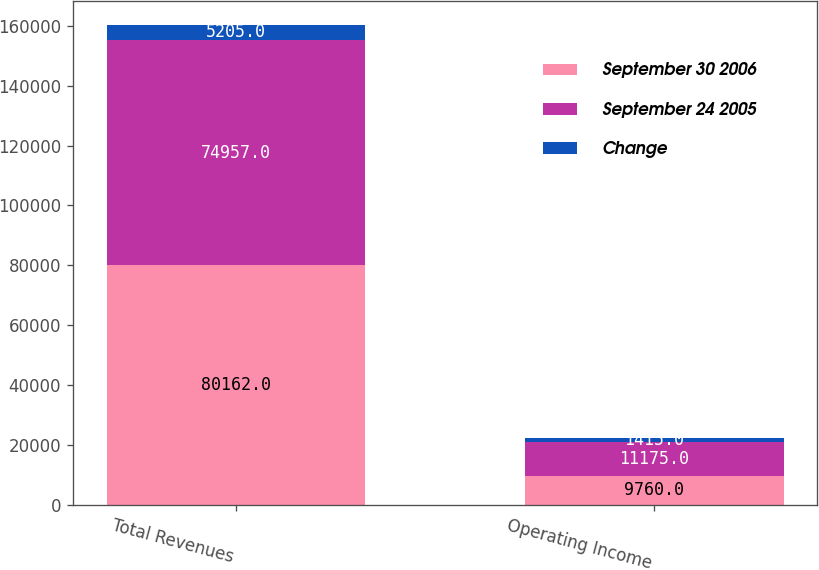Convert chart. <chart><loc_0><loc_0><loc_500><loc_500><stacked_bar_chart><ecel><fcel>Total Revenues<fcel>Operating Income<nl><fcel>September 30 2006<fcel>80162<fcel>9760<nl><fcel>September 24 2005<fcel>74957<fcel>11175<nl><fcel>Change<fcel>5205<fcel>1415<nl></chart> 